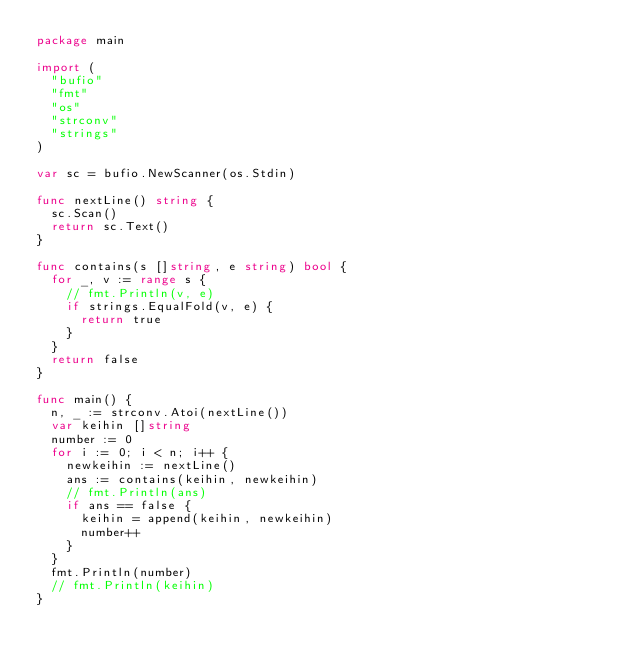<code> <loc_0><loc_0><loc_500><loc_500><_Go_>package main

import (
	"bufio"
	"fmt"
	"os"
	"strconv"
	"strings"
)

var sc = bufio.NewScanner(os.Stdin)

func nextLine() string {
	sc.Scan()
	return sc.Text()
}

func contains(s []string, e string) bool {
	for _, v := range s {
		// fmt.Println(v, e)
		if strings.EqualFold(v, e) {
			return true
		}
	}
	return false
}

func main() {
	n, _ := strconv.Atoi(nextLine())
	var keihin []string
	number := 0
	for i := 0; i < n; i++ {
		newkeihin := nextLine()
		ans := contains(keihin, newkeihin)
		// fmt.Println(ans)
		if ans == false {
			keihin = append(keihin, newkeihin)
			number++
		}
	}
	fmt.Println(number)
	// fmt.Println(keihin)
}
</code> 